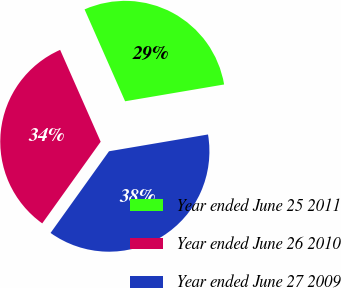<chart> <loc_0><loc_0><loc_500><loc_500><pie_chart><fcel>Year ended June 25 2011<fcel>Year ended June 26 2010<fcel>Year ended June 27 2009<nl><fcel>28.94%<fcel>33.5%<fcel>37.56%<nl></chart> 